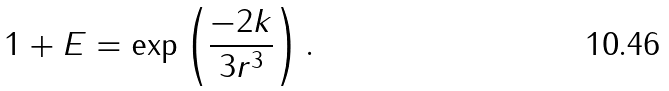Convert formula to latex. <formula><loc_0><loc_0><loc_500><loc_500>1 + E = \exp \left ( \frac { - 2 k } { 3 r ^ { 3 } } \right ) .</formula> 